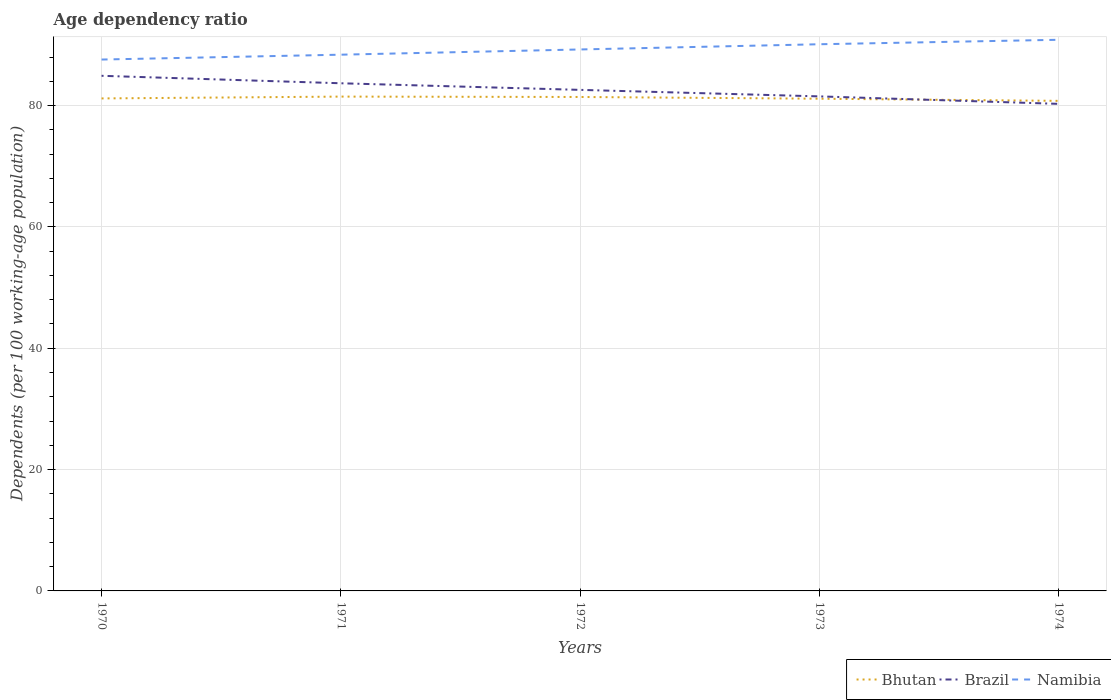Does the line corresponding to Bhutan intersect with the line corresponding to Brazil?
Offer a very short reply. Yes. Across all years, what is the maximum age dependency ratio in in Brazil?
Provide a succinct answer. 80.28. In which year was the age dependency ratio in in Bhutan maximum?
Ensure brevity in your answer.  1974. What is the total age dependency ratio in in Namibia in the graph?
Keep it short and to the point. -3.26. What is the difference between the highest and the second highest age dependency ratio in in Bhutan?
Provide a succinct answer. 0.7. What is the difference between the highest and the lowest age dependency ratio in in Namibia?
Offer a terse response. 3. How many years are there in the graph?
Your response must be concise. 5. What is the difference between two consecutive major ticks on the Y-axis?
Offer a terse response. 20. Are the values on the major ticks of Y-axis written in scientific E-notation?
Provide a short and direct response. No. Does the graph contain any zero values?
Offer a very short reply. No. Does the graph contain grids?
Offer a terse response. Yes. Where does the legend appear in the graph?
Your answer should be very brief. Bottom right. How many legend labels are there?
Provide a succinct answer. 3. How are the legend labels stacked?
Offer a very short reply. Horizontal. What is the title of the graph?
Your answer should be compact. Age dependency ratio. Does "Haiti" appear as one of the legend labels in the graph?
Give a very brief answer. No. What is the label or title of the X-axis?
Provide a succinct answer. Years. What is the label or title of the Y-axis?
Give a very brief answer. Dependents (per 100 working-age population). What is the Dependents (per 100 working-age population) in Bhutan in 1970?
Your answer should be compact. 81.18. What is the Dependents (per 100 working-age population) of Brazil in 1970?
Offer a terse response. 84.91. What is the Dependents (per 100 working-age population) of Namibia in 1970?
Keep it short and to the point. 87.59. What is the Dependents (per 100 working-age population) in Bhutan in 1971?
Your response must be concise. 81.48. What is the Dependents (per 100 working-age population) in Brazil in 1971?
Provide a short and direct response. 83.68. What is the Dependents (per 100 working-age population) of Namibia in 1971?
Your response must be concise. 88.39. What is the Dependents (per 100 working-age population) in Bhutan in 1972?
Provide a succinct answer. 81.42. What is the Dependents (per 100 working-age population) of Brazil in 1972?
Your answer should be very brief. 82.59. What is the Dependents (per 100 working-age population) of Namibia in 1972?
Your response must be concise. 89.25. What is the Dependents (per 100 working-age population) of Bhutan in 1973?
Keep it short and to the point. 81.13. What is the Dependents (per 100 working-age population) of Brazil in 1973?
Give a very brief answer. 81.52. What is the Dependents (per 100 working-age population) of Namibia in 1973?
Give a very brief answer. 90.11. What is the Dependents (per 100 working-age population) of Bhutan in 1974?
Provide a short and direct response. 80.78. What is the Dependents (per 100 working-age population) of Brazil in 1974?
Provide a short and direct response. 80.28. What is the Dependents (per 100 working-age population) of Namibia in 1974?
Offer a terse response. 90.85. Across all years, what is the maximum Dependents (per 100 working-age population) of Bhutan?
Offer a very short reply. 81.48. Across all years, what is the maximum Dependents (per 100 working-age population) in Brazil?
Keep it short and to the point. 84.91. Across all years, what is the maximum Dependents (per 100 working-age population) in Namibia?
Your answer should be very brief. 90.85. Across all years, what is the minimum Dependents (per 100 working-age population) of Bhutan?
Provide a short and direct response. 80.78. Across all years, what is the minimum Dependents (per 100 working-age population) of Brazil?
Offer a very short reply. 80.28. Across all years, what is the minimum Dependents (per 100 working-age population) in Namibia?
Make the answer very short. 87.59. What is the total Dependents (per 100 working-age population) in Bhutan in the graph?
Give a very brief answer. 405.99. What is the total Dependents (per 100 working-age population) in Brazil in the graph?
Your answer should be compact. 412.97. What is the total Dependents (per 100 working-age population) of Namibia in the graph?
Give a very brief answer. 446.18. What is the difference between the Dependents (per 100 working-age population) of Bhutan in 1970 and that in 1971?
Keep it short and to the point. -0.3. What is the difference between the Dependents (per 100 working-age population) of Brazil in 1970 and that in 1971?
Ensure brevity in your answer.  1.23. What is the difference between the Dependents (per 100 working-age population) of Namibia in 1970 and that in 1971?
Ensure brevity in your answer.  -0.8. What is the difference between the Dependents (per 100 working-age population) in Bhutan in 1970 and that in 1972?
Make the answer very short. -0.24. What is the difference between the Dependents (per 100 working-age population) in Brazil in 1970 and that in 1972?
Offer a very short reply. 2.32. What is the difference between the Dependents (per 100 working-age population) in Namibia in 1970 and that in 1972?
Ensure brevity in your answer.  -1.66. What is the difference between the Dependents (per 100 working-age population) of Bhutan in 1970 and that in 1973?
Offer a very short reply. 0.05. What is the difference between the Dependents (per 100 working-age population) in Brazil in 1970 and that in 1973?
Your answer should be compact. 3.39. What is the difference between the Dependents (per 100 working-age population) in Namibia in 1970 and that in 1973?
Keep it short and to the point. -2.52. What is the difference between the Dependents (per 100 working-age population) in Bhutan in 1970 and that in 1974?
Provide a short and direct response. 0.4. What is the difference between the Dependents (per 100 working-age population) of Brazil in 1970 and that in 1974?
Your answer should be very brief. 4.62. What is the difference between the Dependents (per 100 working-age population) of Namibia in 1970 and that in 1974?
Provide a short and direct response. -3.26. What is the difference between the Dependents (per 100 working-age population) in Bhutan in 1971 and that in 1972?
Ensure brevity in your answer.  0.06. What is the difference between the Dependents (per 100 working-age population) in Brazil in 1971 and that in 1972?
Offer a terse response. 1.09. What is the difference between the Dependents (per 100 working-age population) in Namibia in 1971 and that in 1972?
Provide a short and direct response. -0.86. What is the difference between the Dependents (per 100 working-age population) in Bhutan in 1971 and that in 1973?
Provide a short and direct response. 0.35. What is the difference between the Dependents (per 100 working-age population) of Brazil in 1971 and that in 1973?
Your answer should be compact. 2.16. What is the difference between the Dependents (per 100 working-age population) in Namibia in 1971 and that in 1973?
Offer a terse response. -1.72. What is the difference between the Dependents (per 100 working-age population) in Bhutan in 1971 and that in 1974?
Offer a terse response. 0.7. What is the difference between the Dependents (per 100 working-age population) of Brazil in 1971 and that in 1974?
Give a very brief answer. 3.39. What is the difference between the Dependents (per 100 working-age population) of Namibia in 1971 and that in 1974?
Your answer should be compact. -2.46. What is the difference between the Dependents (per 100 working-age population) of Bhutan in 1972 and that in 1973?
Ensure brevity in your answer.  0.29. What is the difference between the Dependents (per 100 working-age population) in Brazil in 1972 and that in 1973?
Give a very brief answer. 1.07. What is the difference between the Dependents (per 100 working-age population) in Namibia in 1972 and that in 1973?
Your response must be concise. -0.86. What is the difference between the Dependents (per 100 working-age population) in Bhutan in 1972 and that in 1974?
Offer a terse response. 0.64. What is the difference between the Dependents (per 100 working-age population) of Brazil in 1972 and that in 1974?
Give a very brief answer. 2.31. What is the difference between the Dependents (per 100 working-age population) in Namibia in 1972 and that in 1974?
Your response must be concise. -1.6. What is the difference between the Dependents (per 100 working-age population) of Bhutan in 1973 and that in 1974?
Keep it short and to the point. 0.35. What is the difference between the Dependents (per 100 working-age population) of Brazil in 1973 and that in 1974?
Your answer should be very brief. 1.23. What is the difference between the Dependents (per 100 working-age population) in Namibia in 1973 and that in 1974?
Offer a terse response. -0.74. What is the difference between the Dependents (per 100 working-age population) of Bhutan in 1970 and the Dependents (per 100 working-age population) of Brazil in 1971?
Ensure brevity in your answer.  -2.5. What is the difference between the Dependents (per 100 working-age population) of Bhutan in 1970 and the Dependents (per 100 working-age population) of Namibia in 1971?
Ensure brevity in your answer.  -7.21. What is the difference between the Dependents (per 100 working-age population) of Brazil in 1970 and the Dependents (per 100 working-age population) of Namibia in 1971?
Keep it short and to the point. -3.48. What is the difference between the Dependents (per 100 working-age population) of Bhutan in 1970 and the Dependents (per 100 working-age population) of Brazil in 1972?
Your answer should be very brief. -1.41. What is the difference between the Dependents (per 100 working-age population) in Bhutan in 1970 and the Dependents (per 100 working-age population) in Namibia in 1972?
Offer a very short reply. -8.07. What is the difference between the Dependents (per 100 working-age population) of Brazil in 1970 and the Dependents (per 100 working-age population) of Namibia in 1972?
Your answer should be very brief. -4.34. What is the difference between the Dependents (per 100 working-age population) in Bhutan in 1970 and the Dependents (per 100 working-age population) in Brazil in 1973?
Keep it short and to the point. -0.34. What is the difference between the Dependents (per 100 working-age population) in Bhutan in 1970 and the Dependents (per 100 working-age population) in Namibia in 1973?
Provide a succinct answer. -8.93. What is the difference between the Dependents (per 100 working-age population) in Brazil in 1970 and the Dependents (per 100 working-age population) in Namibia in 1973?
Offer a terse response. -5.2. What is the difference between the Dependents (per 100 working-age population) of Bhutan in 1970 and the Dependents (per 100 working-age population) of Brazil in 1974?
Offer a terse response. 0.9. What is the difference between the Dependents (per 100 working-age population) of Bhutan in 1970 and the Dependents (per 100 working-age population) of Namibia in 1974?
Your answer should be very brief. -9.67. What is the difference between the Dependents (per 100 working-age population) in Brazil in 1970 and the Dependents (per 100 working-age population) in Namibia in 1974?
Your answer should be very brief. -5.94. What is the difference between the Dependents (per 100 working-age population) of Bhutan in 1971 and the Dependents (per 100 working-age population) of Brazil in 1972?
Offer a very short reply. -1.11. What is the difference between the Dependents (per 100 working-age population) of Bhutan in 1971 and the Dependents (per 100 working-age population) of Namibia in 1972?
Offer a terse response. -7.77. What is the difference between the Dependents (per 100 working-age population) in Brazil in 1971 and the Dependents (per 100 working-age population) in Namibia in 1972?
Your answer should be very brief. -5.57. What is the difference between the Dependents (per 100 working-age population) in Bhutan in 1971 and the Dependents (per 100 working-age population) in Brazil in 1973?
Ensure brevity in your answer.  -0.04. What is the difference between the Dependents (per 100 working-age population) of Bhutan in 1971 and the Dependents (per 100 working-age population) of Namibia in 1973?
Give a very brief answer. -8.63. What is the difference between the Dependents (per 100 working-age population) in Brazil in 1971 and the Dependents (per 100 working-age population) in Namibia in 1973?
Provide a short and direct response. -6.43. What is the difference between the Dependents (per 100 working-age population) of Bhutan in 1971 and the Dependents (per 100 working-age population) of Brazil in 1974?
Offer a very short reply. 1.2. What is the difference between the Dependents (per 100 working-age population) in Bhutan in 1971 and the Dependents (per 100 working-age population) in Namibia in 1974?
Offer a terse response. -9.37. What is the difference between the Dependents (per 100 working-age population) of Brazil in 1971 and the Dependents (per 100 working-age population) of Namibia in 1974?
Make the answer very short. -7.17. What is the difference between the Dependents (per 100 working-age population) in Bhutan in 1972 and the Dependents (per 100 working-age population) in Brazil in 1973?
Provide a succinct answer. -0.1. What is the difference between the Dependents (per 100 working-age population) of Bhutan in 1972 and the Dependents (per 100 working-age population) of Namibia in 1973?
Provide a short and direct response. -8.69. What is the difference between the Dependents (per 100 working-age population) in Brazil in 1972 and the Dependents (per 100 working-age population) in Namibia in 1973?
Give a very brief answer. -7.52. What is the difference between the Dependents (per 100 working-age population) in Bhutan in 1972 and the Dependents (per 100 working-age population) in Brazil in 1974?
Make the answer very short. 1.13. What is the difference between the Dependents (per 100 working-age population) of Bhutan in 1972 and the Dependents (per 100 working-age population) of Namibia in 1974?
Provide a succinct answer. -9.43. What is the difference between the Dependents (per 100 working-age population) in Brazil in 1972 and the Dependents (per 100 working-age population) in Namibia in 1974?
Offer a very short reply. -8.26. What is the difference between the Dependents (per 100 working-age population) in Bhutan in 1973 and the Dependents (per 100 working-age population) in Brazil in 1974?
Keep it short and to the point. 0.85. What is the difference between the Dependents (per 100 working-age population) in Bhutan in 1973 and the Dependents (per 100 working-age population) in Namibia in 1974?
Make the answer very short. -9.71. What is the difference between the Dependents (per 100 working-age population) of Brazil in 1973 and the Dependents (per 100 working-age population) of Namibia in 1974?
Offer a terse response. -9.33. What is the average Dependents (per 100 working-age population) in Bhutan per year?
Keep it short and to the point. 81.2. What is the average Dependents (per 100 working-age population) of Brazil per year?
Offer a very short reply. 82.59. What is the average Dependents (per 100 working-age population) in Namibia per year?
Give a very brief answer. 89.24. In the year 1970, what is the difference between the Dependents (per 100 working-age population) in Bhutan and Dependents (per 100 working-age population) in Brazil?
Ensure brevity in your answer.  -3.73. In the year 1970, what is the difference between the Dependents (per 100 working-age population) of Bhutan and Dependents (per 100 working-age population) of Namibia?
Your response must be concise. -6.41. In the year 1970, what is the difference between the Dependents (per 100 working-age population) in Brazil and Dependents (per 100 working-age population) in Namibia?
Make the answer very short. -2.68. In the year 1971, what is the difference between the Dependents (per 100 working-age population) of Bhutan and Dependents (per 100 working-age population) of Brazil?
Keep it short and to the point. -2.2. In the year 1971, what is the difference between the Dependents (per 100 working-age population) of Bhutan and Dependents (per 100 working-age population) of Namibia?
Offer a very short reply. -6.91. In the year 1971, what is the difference between the Dependents (per 100 working-age population) in Brazil and Dependents (per 100 working-age population) in Namibia?
Your answer should be very brief. -4.71. In the year 1972, what is the difference between the Dependents (per 100 working-age population) of Bhutan and Dependents (per 100 working-age population) of Brazil?
Give a very brief answer. -1.17. In the year 1972, what is the difference between the Dependents (per 100 working-age population) in Bhutan and Dependents (per 100 working-age population) in Namibia?
Offer a very short reply. -7.83. In the year 1972, what is the difference between the Dependents (per 100 working-age population) of Brazil and Dependents (per 100 working-age population) of Namibia?
Offer a terse response. -6.66. In the year 1973, what is the difference between the Dependents (per 100 working-age population) of Bhutan and Dependents (per 100 working-age population) of Brazil?
Offer a very short reply. -0.38. In the year 1973, what is the difference between the Dependents (per 100 working-age population) of Bhutan and Dependents (per 100 working-age population) of Namibia?
Offer a terse response. -8.98. In the year 1973, what is the difference between the Dependents (per 100 working-age population) in Brazil and Dependents (per 100 working-age population) in Namibia?
Your answer should be very brief. -8.59. In the year 1974, what is the difference between the Dependents (per 100 working-age population) of Bhutan and Dependents (per 100 working-age population) of Brazil?
Give a very brief answer. 0.49. In the year 1974, what is the difference between the Dependents (per 100 working-age population) in Bhutan and Dependents (per 100 working-age population) in Namibia?
Provide a short and direct response. -10.07. In the year 1974, what is the difference between the Dependents (per 100 working-age population) in Brazil and Dependents (per 100 working-age population) in Namibia?
Give a very brief answer. -10.56. What is the ratio of the Dependents (per 100 working-age population) in Brazil in 1970 to that in 1971?
Give a very brief answer. 1.01. What is the ratio of the Dependents (per 100 working-age population) of Namibia in 1970 to that in 1971?
Offer a very short reply. 0.99. What is the ratio of the Dependents (per 100 working-age population) in Bhutan in 1970 to that in 1972?
Your answer should be very brief. 1. What is the ratio of the Dependents (per 100 working-age population) in Brazil in 1970 to that in 1972?
Make the answer very short. 1.03. What is the ratio of the Dependents (per 100 working-age population) in Namibia in 1970 to that in 1972?
Provide a succinct answer. 0.98. What is the ratio of the Dependents (per 100 working-age population) in Bhutan in 1970 to that in 1973?
Provide a short and direct response. 1. What is the ratio of the Dependents (per 100 working-age population) in Brazil in 1970 to that in 1973?
Provide a succinct answer. 1.04. What is the ratio of the Dependents (per 100 working-age population) of Namibia in 1970 to that in 1973?
Keep it short and to the point. 0.97. What is the ratio of the Dependents (per 100 working-age population) in Brazil in 1970 to that in 1974?
Ensure brevity in your answer.  1.06. What is the ratio of the Dependents (per 100 working-age population) in Namibia in 1970 to that in 1974?
Provide a short and direct response. 0.96. What is the ratio of the Dependents (per 100 working-age population) in Bhutan in 1971 to that in 1972?
Make the answer very short. 1. What is the ratio of the Dependents (per 100 working-age population) of Brazil in 1971 to that in 1972?
Provide a short and direct response. 1.01. What is the ratio of the Dependents (per 100 working-age population) of Brazil in 1971 to that in 1973?
Give a very brief answer. 1.03. What is the ratio of the Dependents (per 100 working-age population) in Namibia in 1971 to that in 1973?
Your response must be concise. 0.98. What is the ratio of the Dependents (per 100 working-age population) in Bhutan in 1971 to that in 1974?
Provide a succinct answer. 1.01. What is the ratio of the Dependents (per 100 working-age population) of Brazil in 1971 to that in 1974?
Keep it short and to the point. 1.04. What is the ratio of the Dependents (per 100 working-age population) in Namibia in 1971 to that in 1974?
Offer a terse response. 0.97. What is the ratio of the Dependents (per 100 working-age population) in Bhutan in 1972 to that in 1973?
Provide a short and direct response. 1. What is the ratio of the Dependents (per 100 working-age population) of Brazil in 1972 to that in 1973?
Provide a short and direct response. 1.01. What is the ratio of the Dependents (per 100 working-age population) in Bhutan in 1972 to that in 1974?
Give a very brief answer. 1.01. What is the ratio of the Dependents (per 100 working-age population) in Brazil in 1972 to that in 1974?
Your answer should be very brief. 1.03. What is the ratio of the Dependents (per 100 working-age population) of Namibia in 1972 to that in 1974?
Your answer should be compact. 0.98. What is the ratio of the Dependents (per 100 working-age population) in Brazil in 1973 to that in 1974?
Offer a very short reply. 1.02. What is the ratio of the Dependents (per 100 working-age population) of Namibia in 1973 to that in 1974?
Your answer should be compact. 0.99. What is the difference between the highest and the second highest Dependents (per 100 working-age population) of Bhutan?
Keep it short and to the point. 0.06. What is the difference between the highest and the second highest Dependents (per 100 working-age population) in Brazil?
Provide a succinct answer. 1.23. What is the difference between the highest and the second highest Dependents (per 100 working-age population) of Namibia?
Provide a short and direct response. 0.74. What is the difference between the highest and the lowest Dependents (per 100 working-age population) of Bhutan?
Provide a short and direct response. 0.7. What is the difference between the highest and the lowest Dependents (per 100 working-age population) of Brazil?
Make the answer very short. 4.62. What is the difference between the highest and the lowest Dependents (per 100 working-age population) in Namibia?
Keep it short and to the point. 3.26. 